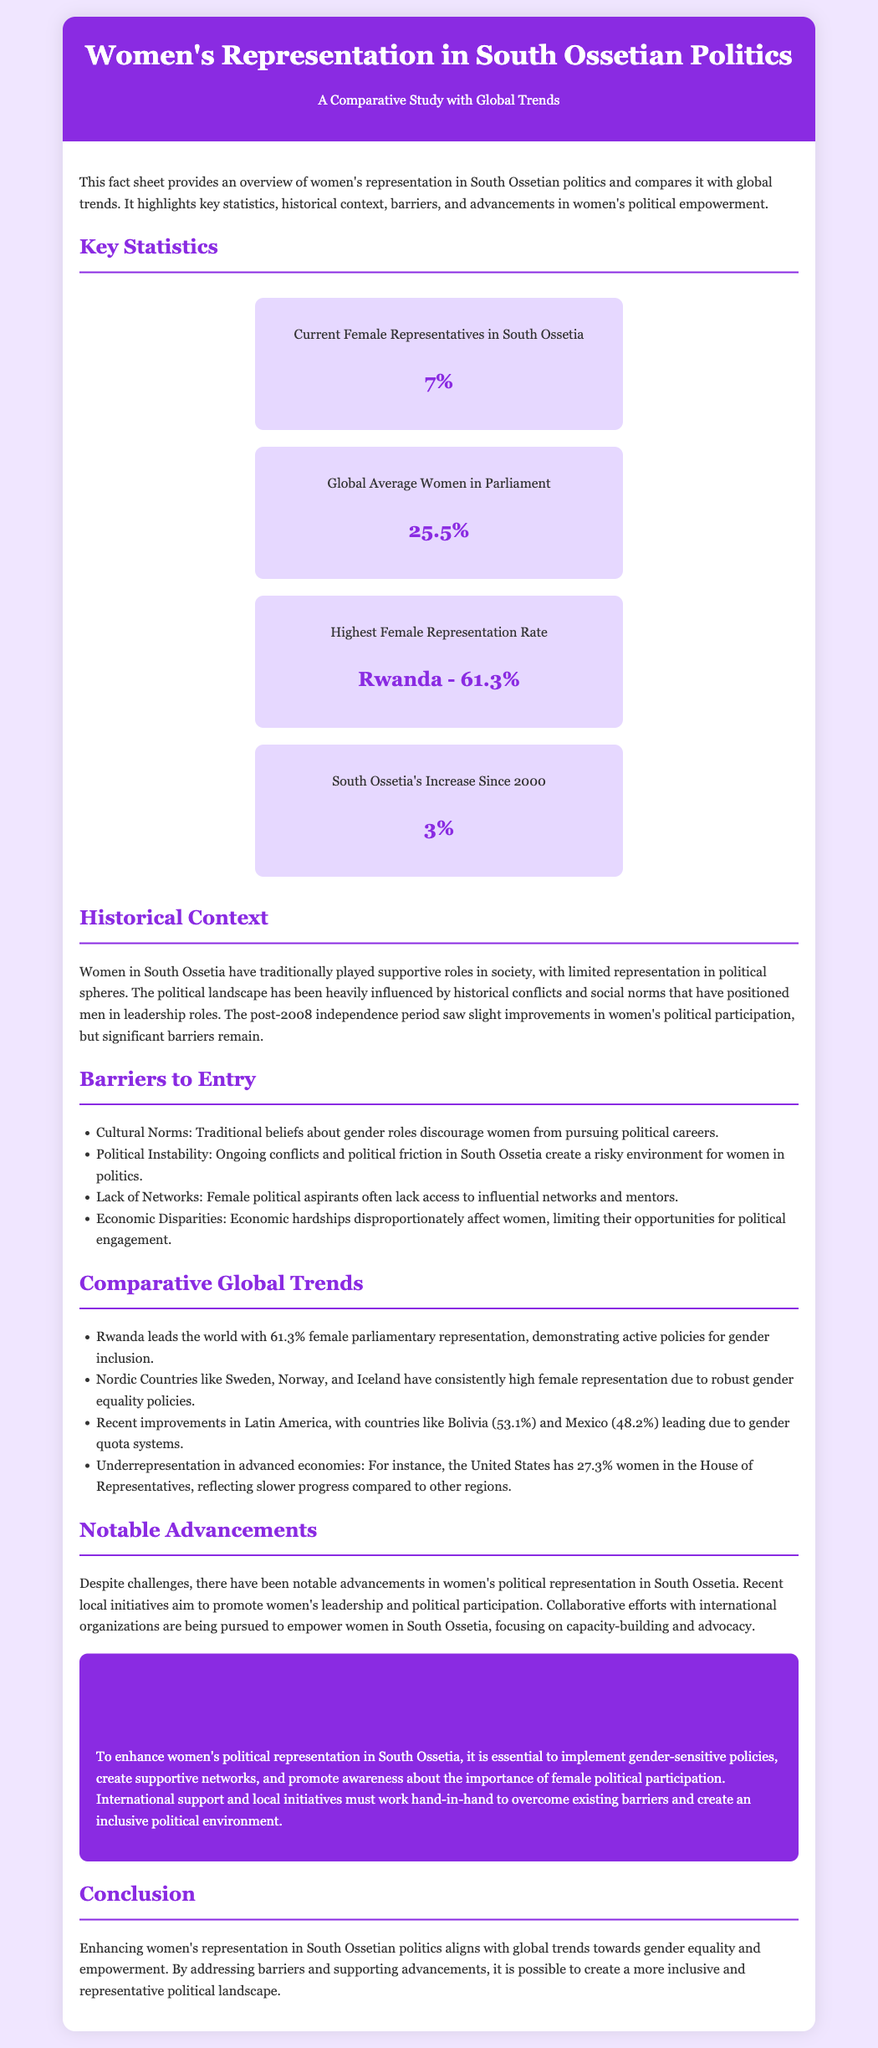What percentage of current female representatives in South Ossetia? The document states that the current female representatives make up 7% of the political landscape in South Ossetia.
Answer: 7% What is the global average for women in parliament? The fact sheet indicates that the global average representation of women in parliament is 25.5%.
Answer: 25.5% What country has the highest female representation rate? According to the document, Rwanda has the highest female representation rate at 61.3%.
Answer: Rwanda - 61.3% What percentage increase has South Ossetia seen since 2000? The document mentions that South Ossetia has seen a 3% increase in female representation since the year 2000.
Answer: 3% What are two barriers to women's political participation listed in the document? The fact sheet lists cultural norms and political instability as barriers to women's political participation in South Ossetia.
Answer: Cultural Norms, Political Instability What is one notable advancement for women in South Ossetia's politics? The document notes that recent local initiatives aim to promote women's leadership and political participation as a notable advancement.
Answer: Local initiatives to promote leadership What does the document suggest is essential to enhance women's political representation? It states that implementing gender-sensitive policies is essential for enhancing women's political representation in South Ossetia.
Answer: Gender-sensitive policies Which region is mentioned as having consistently high female representation due to gender equality policies? The document refers to Nordic Countries as having consistently high female representation due to robust gender equality policies.
Answer: Nordic Countries What is a key goal of collaborative efforts with international organizations? The document highlights that the goal is to empower women in South Ossetia through capacity-building and advocacy.
Answer: Capacity-building and advocacy 